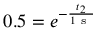Convert formula to latex. <formula><loc_0><loc_0><loc_500><loc_500>0 . 5 = e ^ { - \frac { t _ { 2 } } { 1 s } }</formula> 